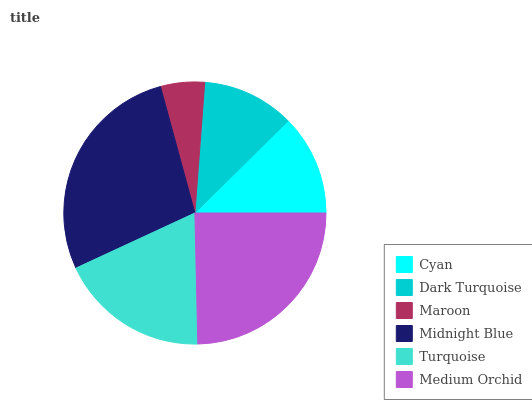Is Maroon the minimum?
Answer yes or no. Yes. Is Midnight Blue the maximum?
Answer yes or no. Yes. Is Dark Turquoise the minimum?
Answer yes or no. No. Is Dark Turquoise the maximum?
Answer yes or no. No. Is Cyan greater than Dark Turquoise?
Answer yes or no. Yes. Is Dark Turquoise less than Cyan?
Answer yes or no. Yes. Is Dark Turquoise greater than Cyan?
Answer yes or no. No. Is Cyan less than Dark Turquoise?
Answer yes or no. No. Is Turquoise the high median?
Answer yes or no. Yes. Is Cyan the low median?
Answer yes or no. Yes. Is Cyan the high median?
Answer yes or no. No. Is Midnight Blue the low median?
Answer yes or no. No. 